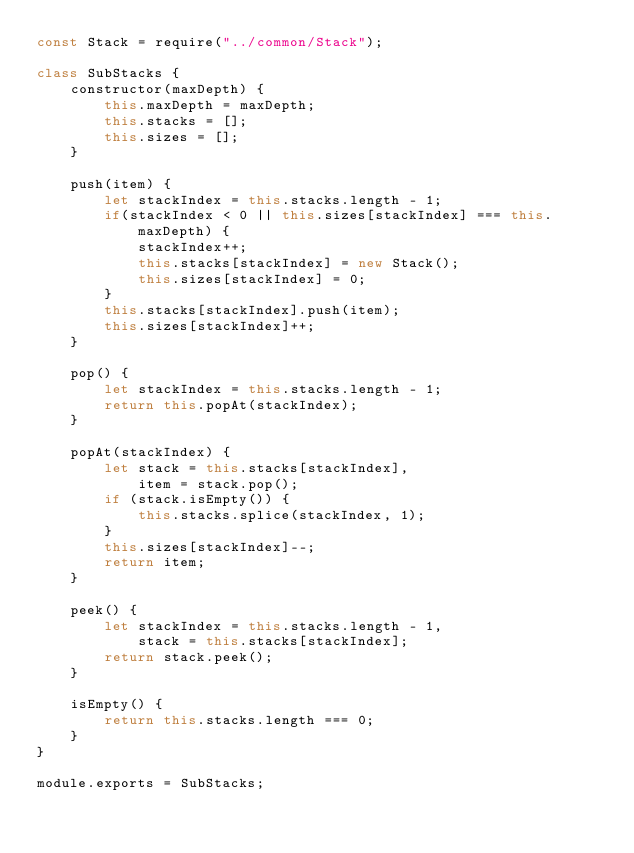Convert code to text. <code><loc_0><loc_0><loc_500><loc_500><_JavaScript_>const Stack = require("../common/Stack");

class SubStacks {
    constructor(maxDepth) {
        this.maxDepth = maxDepth;
        this.stacks = [];
        this.sizes = [];
    }

    push(item) {
        let stackIndex = this.stacks.length - 1;
        if(stackIndex < 0 || this.sizes[stackIndex] === this.maxDepth) {
            stackIndex++;
            this.stacks[stackIndex] = new Stack();
            this.sizes[stackIndex] = 0;
        }
        this.stacks[stackIndex].push(item);
        this.sizes[stackIndex]++;
    }

    pop() {
        let stackIndex = this.stacks.length - 1;
        return this.popAt(stackIndex);
    }

    popAt(stackIndex) {
        let stack = this.stacks[stackIndex],
            item = stack.pop();
        if (stack.isEmpty()) {
            this.stacks.splice(stackIndex, 1);
        }
        this.sizes[stackIndex]--;
        return item;
    }

    peek() {
        let stackIndex = this.stacks.length - 1,
            stack = this.stacks[stackIndex];
        return stack.peek();
    }

    isEmpty() {
        return this.stacks.length === 0;
    }
}

module.exports = SubStacks;</code> 